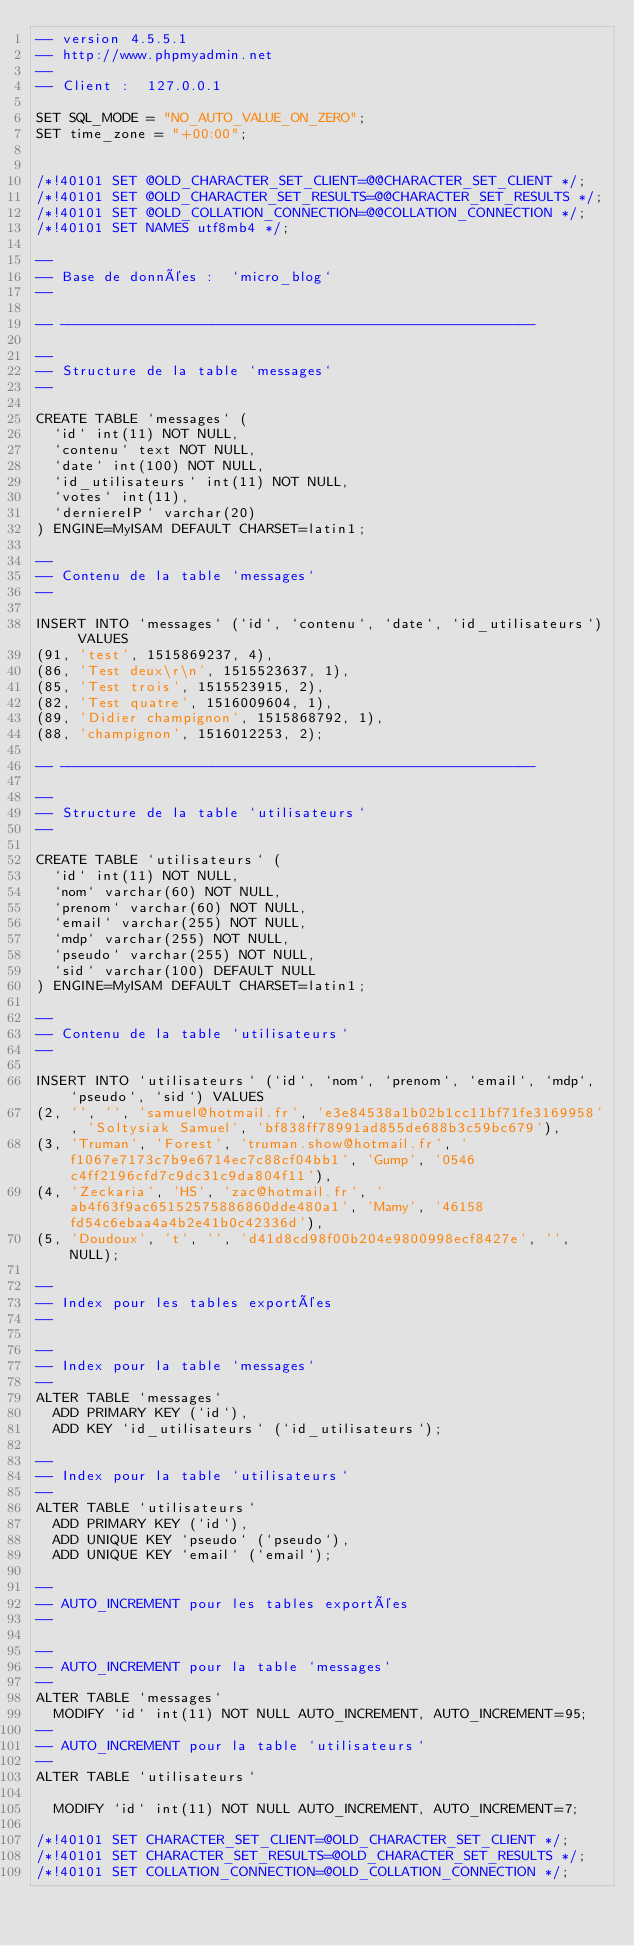Convert code to text. <code><loc_0><loc_0><loc_500><loc_500><_SQL_>-- version 4.5.5.1
-- http://www.phpmyadmin.net
--
-- Client :  127.0.0.1

SET SQL_MODE = "NO_AUTO_VALUE_ON_ZERO";
SET time_zone = "+00:00";


/*!40101 SET @OLD_CHARACTER_SET_CLIENT=@@CHARACTER_SET_CLIENT */;
/*!40101 SET @OLD_CHARACTER_SET_RESULTS=@@CHARACTER_SET_RESULTS */;
/*!40101 SET @OLD_COLLATION_CONNECTION=@@COLLATION_CONNECTION */;
/*!40101 SET NAMES utf8mb4 */;

--
-- Base de données :  `micro_blog`
--

-- --------------------------------------------------------

--
-- Structure de la table `messages`
--

CREATE TABLE `messages` (
  `id` int(11) NOT NULL,
  `contenu` text NOT NULL,
  `date` int(100) NOT NULL,
  `id_utilisateurs` int(11) NOT NULL,
  `votes` int(11),
  `derniereIP` varchar(20) 
) ENGINE=MyISAM DEFAULT CHARSET=latin1;

--
-- Contenu de la table `messages`
--

INSERT INTO `messages` (`id`, `contenu`, `date`, `id_utilisateurs`) VALUES
(91, 'test', 1515869237, 4),
(86, 'Test deux\r\n', 1515523637, 1),
(85, 'Test trois', 1515523915, 2),
(82, 'Test quatre', 1516009604, 1),
(89, 'Didier champignon', 1515868792, 1),
(88, 'champignon', 1516012253, 2);

-- --------------------------------------------------------

--
-- Structure de la table `utilisateurs`
--

CREATE TABLE `utilisateurs` (
  `id` int(11) NOT NULL,
  `nom` varchar(60) NOT NULL,
  `prenom` varchar(60) NOT NULL,
  `email` varchar(255) NOT NULL,
  `mdp` varchar(255) NOT NULL,
  `pseudo` varchar(255) NOT NULL,
  `sid` varchar(100) DEFAULT NULL
) ENGINE=MyISAM DEFAULT CHARSET=latin1;

--
-- Contenu de la table `utilisateurs`
--

INSERT INTO `utilisateurs` (`id`, `nom`, `prenom`, `email`, `mdp`, `pseudo`, `sid`) VALUES
(2, '', '', 'samuel@hotmail.fr', 'e3e84538a1b02b1cc11bf71fe3169958', 'Soltysiak Samuel', 'bf838ff78991ad855de688b3c59bc679'),
(3, 'Truman', 'Forest', 'truman.show@hotmail.fr', 'f1067e7173c7b9e6714ec7c88cf04bb1', 'Gump', '0546c4ff2196cfd7c9dc31c9da804f11'),
(4, 'Zeckaria', 'HS', 'zac@hotmail.fr', 'ab4f63f9ac65152575886860dde480a1', 'Mamy', '46158fd54c6ebaa4a4b2e41b0c42336d'),
(5, 'Doudoux', 't', '', 'd41d8cd98f00b204e9800998ecf8427e', '', NULL);

--
-- Index pour les tables exportées
--

--
-- Index pour la table `messages`
--
ALTER TABLE `messages`
  ADD PRIMARY KEY (`id`),
  ADD KEY `id_utilisateurs` (`id_utilisateurs`);

--
-- Index pour la table `utilisateurs`
--
ALTER TABLE `utilisateurs`
  ADD PRIMARY KEY (`id`),
  ADD UNIQUE KEY `pseudo` (`pseudo`),
  ADD UNIQUE KEY `email` (`email`);

--
-- AUTO_INCREMENT pour les tables exportées
--

--
-- AUTO_INCREMENT pour la table `messages`
--
ALTER TABLE `messages`
  MODIFY `id` int(11) NOT NULL AUTO_INCREMENT, AUTO_INCREMENT=95;
--
-- AUTO_INCREMENT pour la table `utilisateurs`
--
ALTER TABLE `utilisateurs`

  MODIFY `id` int(11) NOT NULL AUTO_INCREMENT, AUTO_INCREMENT=7;

/*!40101 SET CHARACTER_SET_CLIENT=@OLD_CHARACTER_SET_CLIENT */;
/*!40101 SET CHARACTER_SET_RESULTS=@OLD_CHARACTER_SET_RESULTS */;
/*!40101 SET COLLATION_CONNECTION=@OLD_COLLATION_CONNECTION */;
</code> 